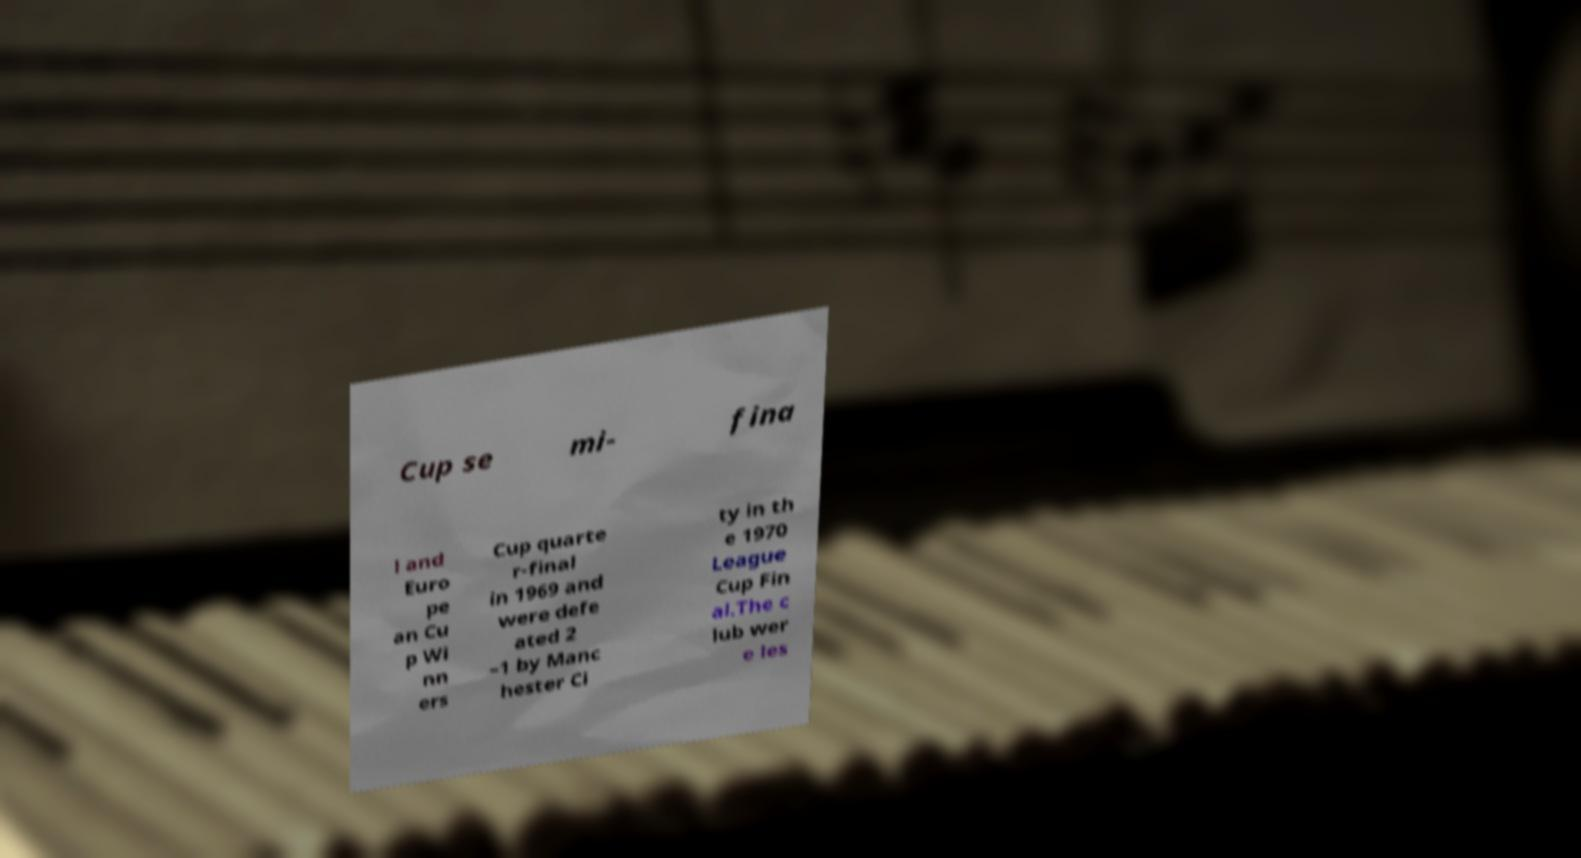Can you accurately transcribe the text from the provided image for me? Cup se mi- fina l and Euro pe an Cu p Wi nn ers Cup quarte r-final in 1969 and were defe ated 2 –1 by Manc hester Ci ty in th e 1970 League Cup Fin al.The c lub wer e les 